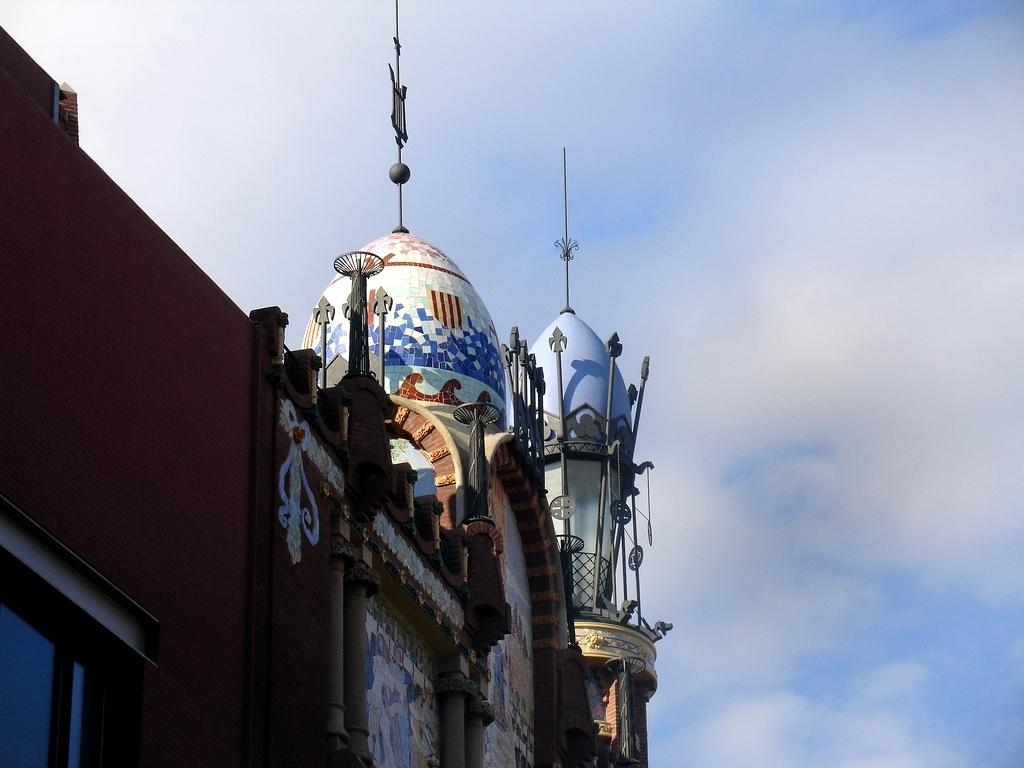What can be seen at the top of the building in the image? The building has a dome at the top. What is the appearance of the dome? The dome has multiple colors. Where is the building located in the image? The building is on the left side of the image. What is visible in the background of the image? The sky is visible in the image. What type of chair is placed near the stew in the image? There is no chair or stew present in the image; it features a building with a dome. How many birds are perched on the dome in the image? There are no birds visible on the dome in the image. 